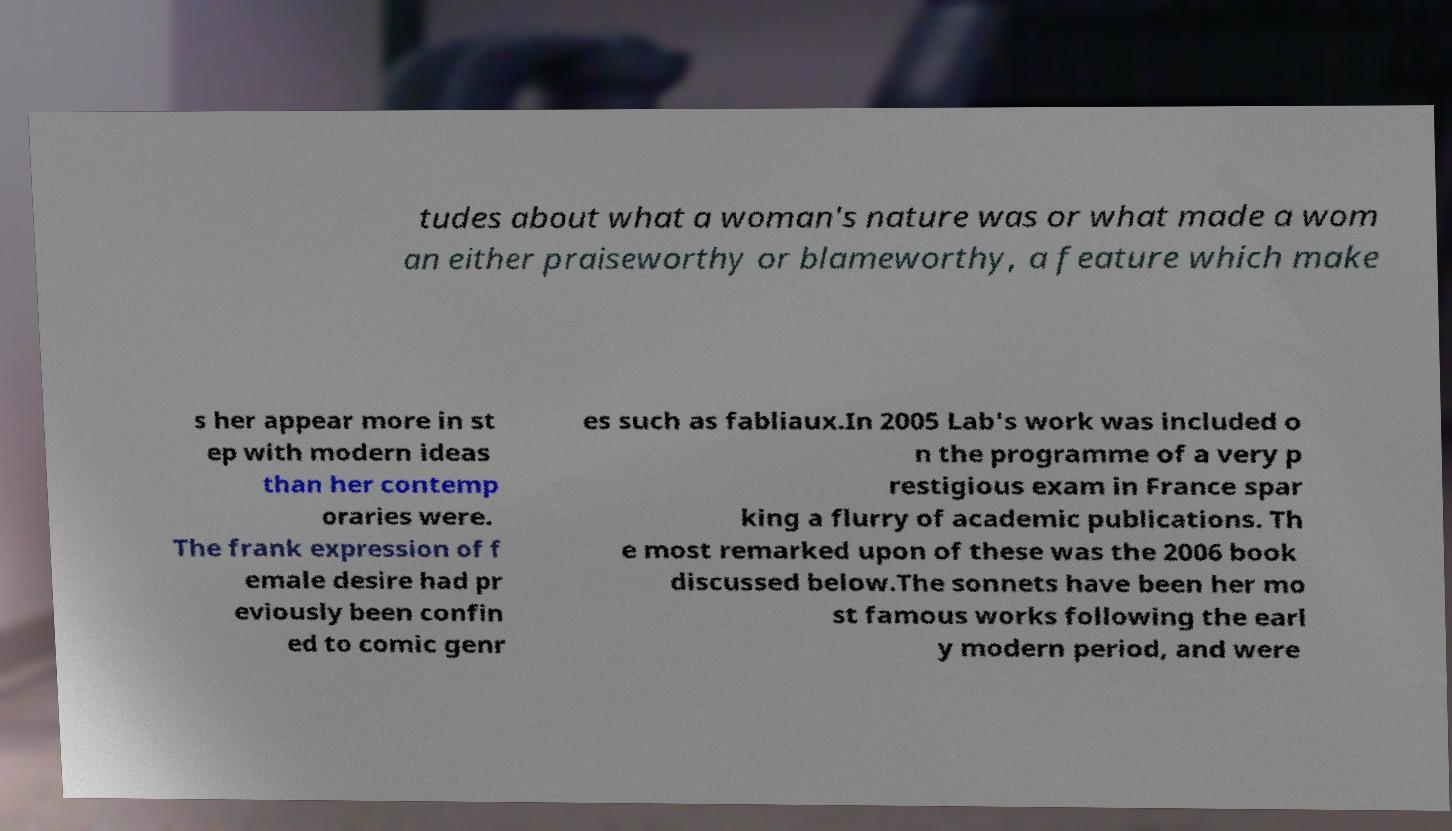I need the written content from this picture converted into text. Can you do that? tudes about what a woman's nature was or what made a wom an either praiseworthy or blameworthy, a feature which make s her appear more in st ep with modern ideas than her contemp oraries were. The frank expression of f emale desire had pr eviously been confin ed to comic genr es such as fabliaux.In 2005 Lab's work was included o n the programme of a very p restigious exam in France spar king a flurry of academic publications. Th e most remarked upon of these was the 2006 book discussed below.The sonnets have been her mo st famous works following the earl y modern period, and were 